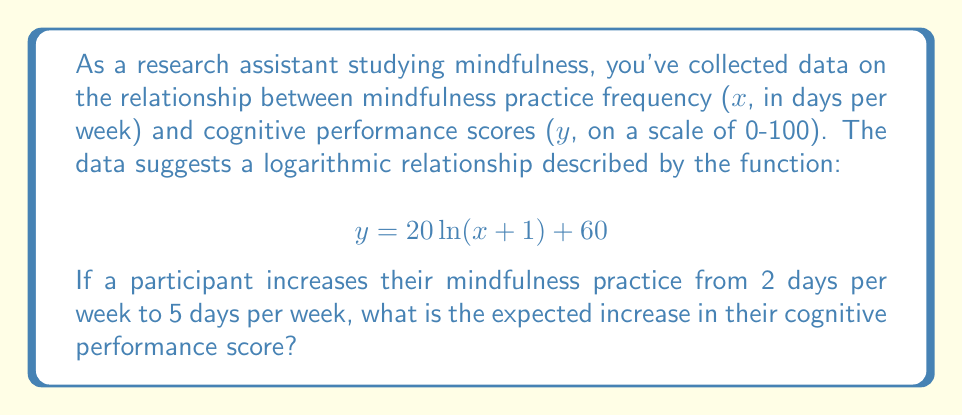Give your solution to this math problem. To solve this problem, we need to:

1. Calculate the cognitive performance score for 2 days of practice per week.
2. Calculate the cognitive performance score for 5 days of practice per week.
3. Find the difference between these two scores.

Step 1: Cognitive performance score for 2 days per week
$$ y_1 = 20 \ln(2 + 1) + 60 $$
$$ y_1 = 20 \ln(3) + 60 $$
$$ y_1 \approx 20 \cdot 1.0986 + 60 $$
$$ y_1 \approx 81.97 $$

Step 2: Cognitive performance score for 5 days per week
$$ y_2 = 20 \ln(5 + 1) + 60 $$
$$ y_2 = 20 \ln(6) + 60 $$
$$ y_2 \approx 20 \cdot 1.7918 + 60 $$
$$ y_2 \approx 95.84 $$

Step 3: Calculate the difference
$$ \text{Increase} = y_2 - y_1 $$
$$ \text{Increase} \approx 95.84 - 81.97 $$
$$ \text{Increase} \approx 13.87 $$

Therefore, the expected increase in cognitive performance score is approximately 13.87 points.
Answer: The expected increase in cognitive performance score is approximately 13.87 points. 